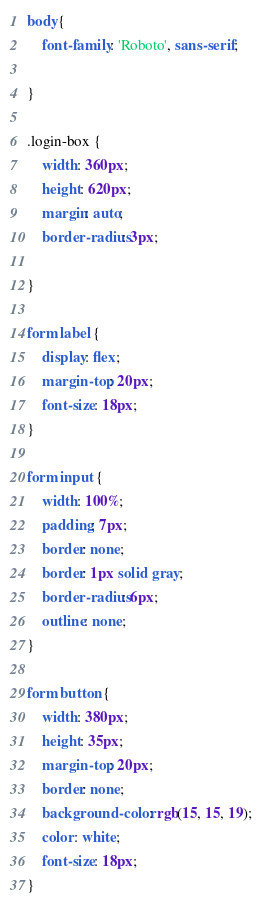<code> <loc_0><loc_0><loc_500><loc_500><_CSS_>body{
    font-family: 'Roboto', sans-serif;

}

.login-box {
    width: 360px;
    height: 620px;
    margin: auto;
    border-radius: 3px;
    
}

form label {
    display: flex;
    margin-top: 20px;
    font-size: 18px;
}

form input {
    width: 100%;
    padding: 7px;
    border: none;
    border: 1px solid gray;
    border-radius: 6px;
    outline: none;
}

form button {
    width: 380px;
    height: 35px;
    margin-top: 20px;
    border: none;
    background-color: rgb(15, 15, 19);
    color: white;
    font-size: 18px;
}</code> 